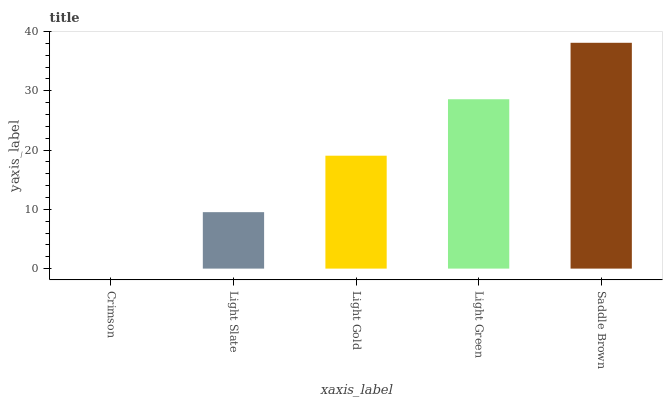Is Crimson the minimum?
Answer yes or no. Yes. Is Saddle Brown the maximum?
Answer yes or no. Yes. Is Light Slate the minimum?
Answer yes or no. No. Is Light Slate the maximum?
Answer yes or no. No. Is Light Slate greater than Crimson?
Answer yes or no. Yes. Is Crimson less than Light Slate?
Answer yes or no. Yes. Is Crimson greater than Light Slate?
Answer yes or no. No. Is Light Slate less than Crimson?
Answer yes or no. No. Is Light Gold the high median?
Answer yes or no. Yes. Is Light Gold the low median?
Answer yes or no. Yes. Is Light Green the high median?
Answer yes or no. No. Is Crimson the low median?
Answer yes or no. No. 